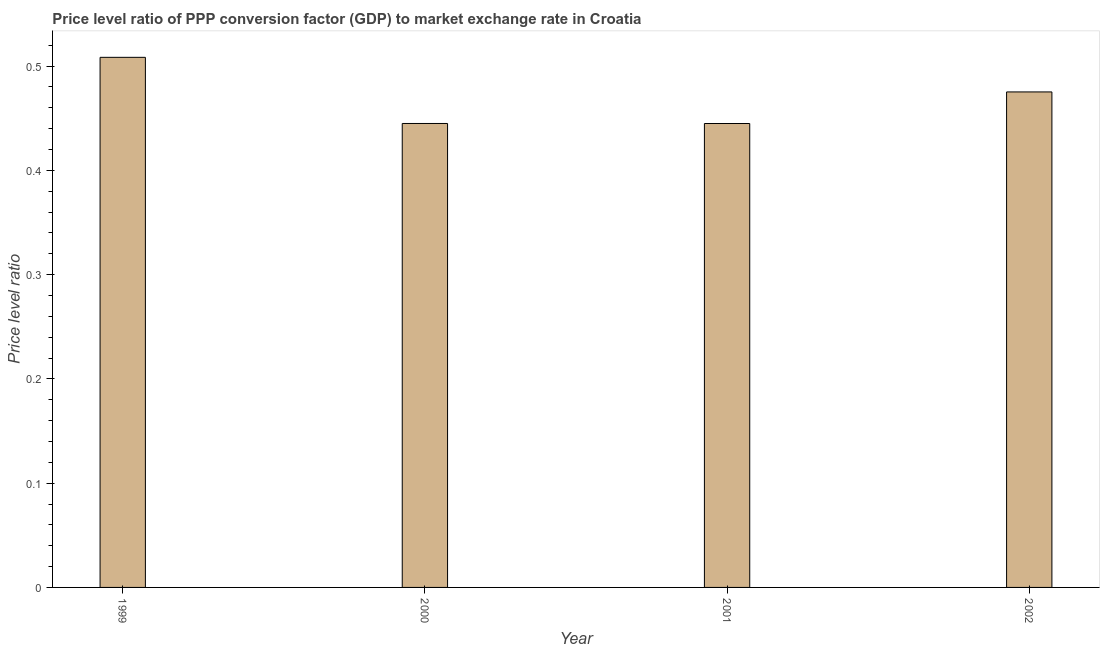What is the title of the graph?
Keep it short and to the point. Price level ratio of PPP conversion factor (GDP) to market exchange rate in Croatia. What is the label or title of the X-axis?
Provide a short and direct response. Year. What is the label or title of the Y-axis?
Keep it short and to the point. Price level ratio. What is the price level ratio in 2000?
Offer a terse response. 0.44. Across all years, what is the maximum price level ratio?
Provide a succinct answer. 0.51. Across all years, what is the minimum price level ratio?
Give a very brief answer. 0.44. In which year was the price level ratio maximum?
Ensure brevity in your answer.  1999. In which year was the price level ratio minimum?
Provide a succinct answer. 2001. What is the sum of the price level ratio?
Provide a succinct answer. 1.87. What is the difference between the price level ratio in 1999 and 2000?
Make the answer very short. 0.06. What is the average price level ratio per year?
Offer a terse response. 0.47. What is the median price level ratio?
Your answer should be compact. 0.46. What is the ratio of the price level ratio in 1999 to that in 2000?
Offer a terse response. 1.14. Is the price level ratio in 2000 less than that in 2001?
Make the answer very short. No. Is the difference between the price level ratio in 2000 and 2001 greater than the difference between any two years?
Your response must be concise. No. What is the difference between the highest and the second highest price level ratio?
Offer a terse response. 0.03. Is the sum of the price level ratio in 1999 and 2001 greater than the maximum price level ratio across all years?
Your answer should be very brief. Yes. Are the values on the major ticks of Y-axis written in scientific E-notation?
Provide a succinct answer. No. What is the Price level ratio in 1999?
Provide a short and direct response. 0.51. What is the Price level ratio of 2000?
Your answer should be very brief. 0.44. What is the Price level ratio of 2001?
Offer a terse response. 0.44. What is the Price level ratio in 2002?
Keep it short and to the point. 0.48. What is the difference between the Price level ratio in 1999 and 2000?
Give a very brief answer. 0.06. What is the difference between the Price level ratio in 1999 and 2001?
Offer a very short reply. 0.06. What is the difference between the Price level ratio in 1999 and 2002?
Ensure brevity in your answer.  0.03. What is the difference between the Price level ratio in 2000 and 2001?
Provide a succinct answer. 3e-5. What is the difference between the Price level ratio in 2000 and 2002?
Your answer should be compact. -0.03. What is the difference between the Price level ratio in 2001 and 2002?
Keep it short and to the point. -0.03. What is the ratio of the Price level ratio in 1999 to that in 2000?
Your answer should be compact. 1.14. What is the ratio of the Price level ratio in 1999 to that in 2001?
Make the answer very short. 1.14. What is the ratio of the Price level ratio in 1999 to that in 2002?
Give a very brief answer. 1.07. What is the ratio of the Price level ratio in 2000 to that in 2002?
Your response must be concise. 0.94. What is the ratio of the Price level ratio in 2001 to that in 2002?
Offer a very short reply. 0.94. 